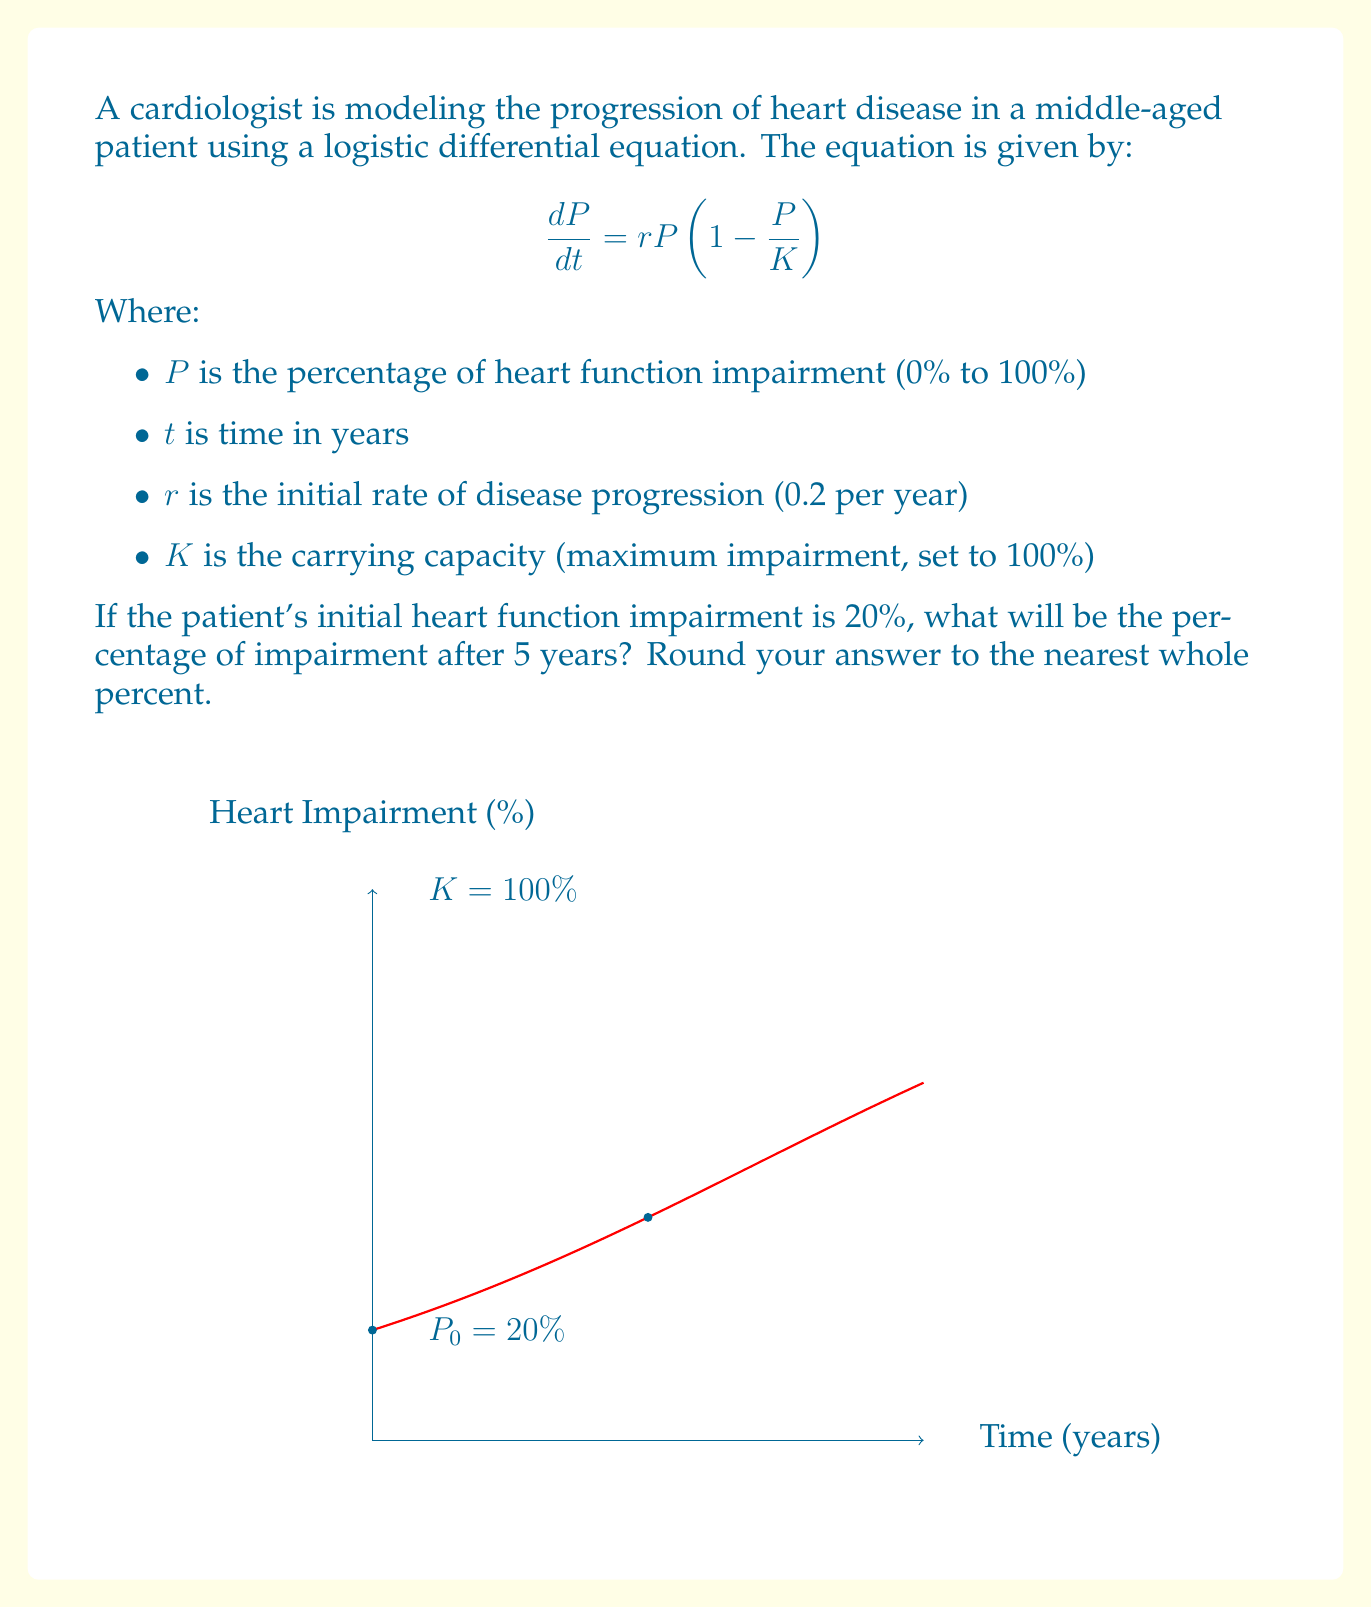What is the answer to this math problem? Let's solve this problem step-by-step:

1) The logistic equation solution is given by:

   $$P(t) = \frac{K}{1 + (\frac{K}{P_0} - 1)e^{-rt}}$$

   Where $P_0$ is the initial impairment.

2) We're given:
   $K = 100\%$
   $r = 0.2$ per year
   $P_0 = 20\%$
   $t = 5$ years

3) Let's substitute these values into the equation:

   $$P(5) = \frac{100}{1 + (\frac{100}{20} - 1)e^{-0.2 \cdot 5}}$$

4) Simplify:
   $$P(5) = \frac{100}{1 + (5 - 1)e^{-1}}$$
   $$P(5) = \frac{100}{1 + 4e^{-1}}$$

5) Calculate $e^{-1} \approx 0.3679$:
   $$P(5) \approx \frac{100}{1 + 4(0.3679)}$$
   $$P(5) \approx \frac{100}{2.4716}$$

6) Divide:
   $$P(5) \approx 40.46\%$$

7) Rounding to the nearest whole percent:
   $$P(5) \approx 40\%$$

Therefore, after 5 years, the heart function impairment will be approximately 40%.
Answer: 40% 